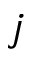<formula> <loc_0><loc_0><loc_500><loc_500>j</formula> 